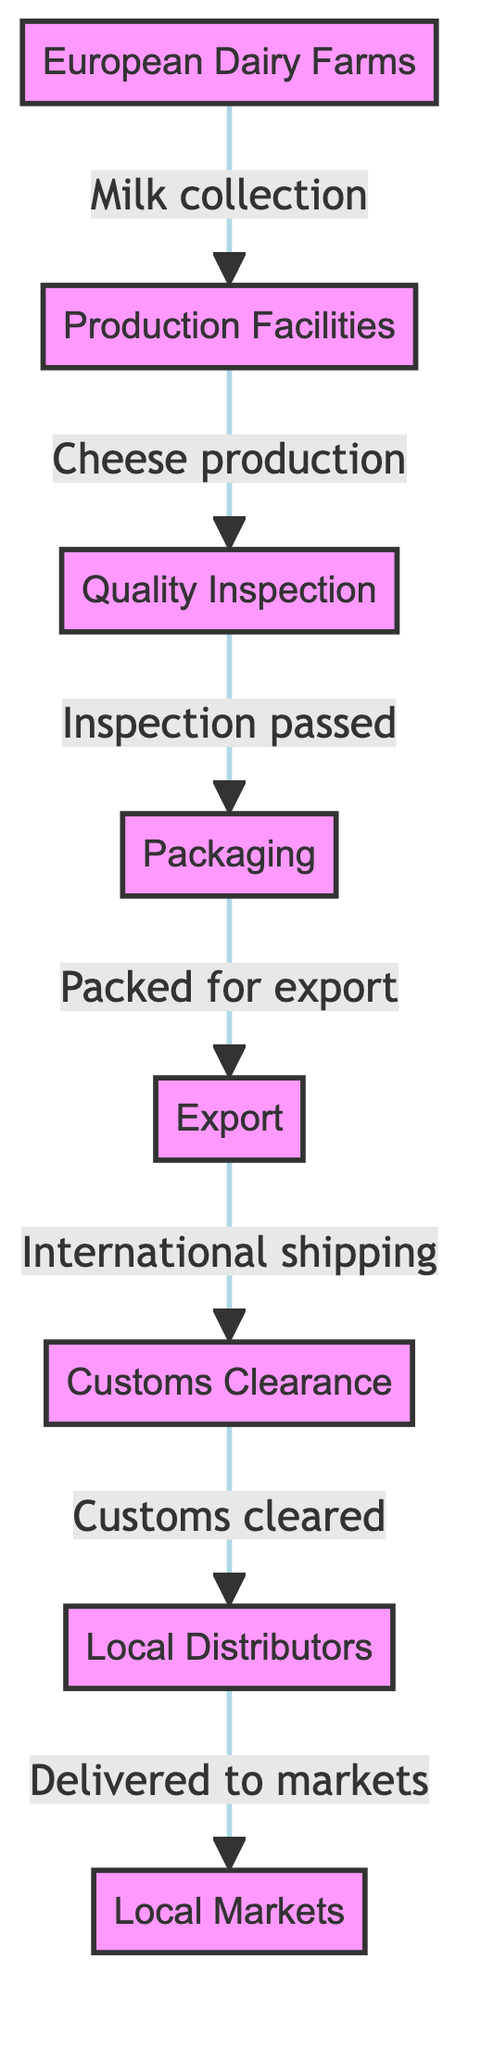What is the first node in the diagram? The first node is labeled "European Dairy Farms," which is the starting point in the flow of producing specialty cheeses.
Answer: European Dairy Farms How many nodes are in the diagram? Counting all entities, there are eight distinct nodes representing different stages in the cheese journey.
Answer: 8 What occurs after quality inspection? After the quality inspection stage, the cheese is moved to the packaging stage, which indicates it is ready for distribution.
Answer: Packaging What comes before customs clearance in the process? The step that precedes customs clearance is the export step, which involves international shipping of the cheese.
Answer: Export How many edges connect the nodes in the diagram? There are seven edges connecting the eight nodes, each representing the flow of processes between them.
Answer: 7 What is the relationship between packaging and export? Packaging is an essential step before export, as it prepares the cheese for international shipping, indicating a direct flow from packaging to export.
Answer: Packed for export What is the last node in this food chain? The last node in the diagram is "Local Markets," which represents the final destination where the specialty cheeses are sold to consumers.
Answer: Local Markets Which node follows local distributors? The local markets node follows the local distributors node, showing the final delivery stage of the cheese journey.
Answer: Local Markets What is inspected right after cheese production in the process? Quality Inspection is the step that occurs immediately after cheese production, ensuring the product meets necessary standards before packaging.
Answer: Quality Inspection 